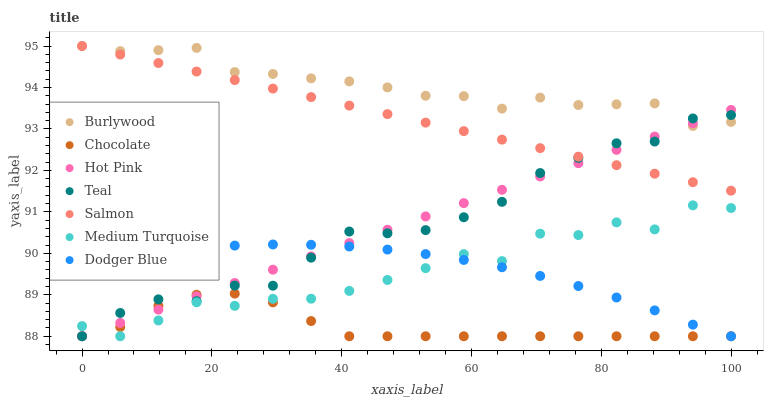Does Chocolate have the minimum area under the curve?
Answer yes or no. Yes. Does Burlywood have the maximum area under the curve?
Answer yes or no. Yes. Does Hot Pink have the minimum area under the curve?
Answer yes or no. No. Does Hot Pink have the maximum area under the curve?
Answer yes or no. No. Is Salmon the smoothest?
Answer yes or no. Yes. Is Medium Turquoise the roughest?
Answer yes or no. Yes. Is Burlywood the smoothest?
Answer yes or no. No. Is Burlywood the roughest?
Answer yes or no. No. Does Teal have the lowest value?
Answer yes or no. Yes. Does Burlywood have the lowest value?
Answer yes or no. No. Does Salmon have the highest value?
Answer yes or no. Yes. Does Hot Pink have the highest value?
Answer yes or no. No. Is Chocolate less than Salmon?
Answer yes or no. Yes. Is Burlywood greater than Dodger Blue?
Answer yes or no. Yes. Does Medium Turquoise intersect Chocolate?
Answer yes or no. Yes. Is Medium Turquoise less than Chocolate?
Answer yes or no. No. Is Medium Turquoise greater than Chocolate?
Answer yes or no. No. Does Chocolate intersect Salmon?
Answer yes or no. No. 